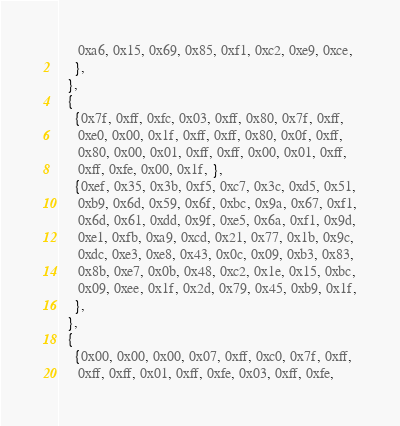Convert code to text. <code><loc_0><loc_0><loc_500><loc_500><_C++_>     0xa6, 0x15, 0x69, 0x85, 0xf1, 0xc2, 0xe9, 0xce,
    },
  },
  {
    {0x7f, 0xff, 0xfc, 0x03, 0xff, 0x80, 0x7f, 0xff,
     0xe0, 0x00, 0x1f, 0xff, 0xff, 0x80, 0x0f, 0xff,
     0x80, 0x00, 0x01, 0xff, 0xff, 0x00, 0x01, 0xff,
     0xff, 0xfe, 0x00, 0x1f, },
    {0xef, 0x35, 0x3b, 0xf5, 0xc7, 0x3c, 0xd5, 0x51,
     0xb9, 0x6d, 0x59, 0x6f, 0xbc, 0x9a, 0x67, 0xf1,
     0x6d, 0x61, 0xdd, 0x9f, 0xe5, 0x6a, 0xf1, 0x9d,
     0xe1, 0xfb, 0xa9, 0xcd, 0x21, 0x77, 0x1b, 0x9c,
     0xdc, 0xe3, 0xe8, 0x43, 0x0c, 0x09, 0xb3, 0x83,
     0x8b, 0xe7, 0x0b, 0x48, 0xc2, 0x1e, 0x15, 0xbc,
     0x09, 0xee, 0x1f, 0x2d, 0x79, 0x45, 0xb9, 0x1f,
    },
  },
  {
    {0x00, 0x00, 0x00, 0x07, 0xff, 0xc0, 0x7f, 0xff,
     0xff, 0xff, 0x01, 0xff, 0xfe, 0x03, 0xff, 0xfe,</code> 